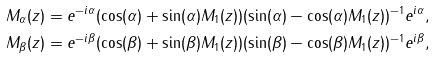<formula> <loc_0><loc_0><loc_500><loc_500>M _ { \alpha } ( z ) & = e ^ { - i \alpha } ( \cos ( \alpha ) + \sin ( \alpha ) M _ { 1 } ( z ) ) ( \sin ( \alpha ) - \cos ( \alpha ) M _ { 1 } ( z ) ) ^ { - 1 } e ^ { i \alpha } , \\ M _ { \beta } ( z ) & = e ^ { - i \beta } ( \cos ( \beta ) + \sin ( \beta ) M _ { 1 } ( z ) ) ( \sin ( \beta ) - \cos ( \beta ) M _ { 1 } ( z ) ) ^ { - 1 } e ^ { i \beta } ,</formula> 